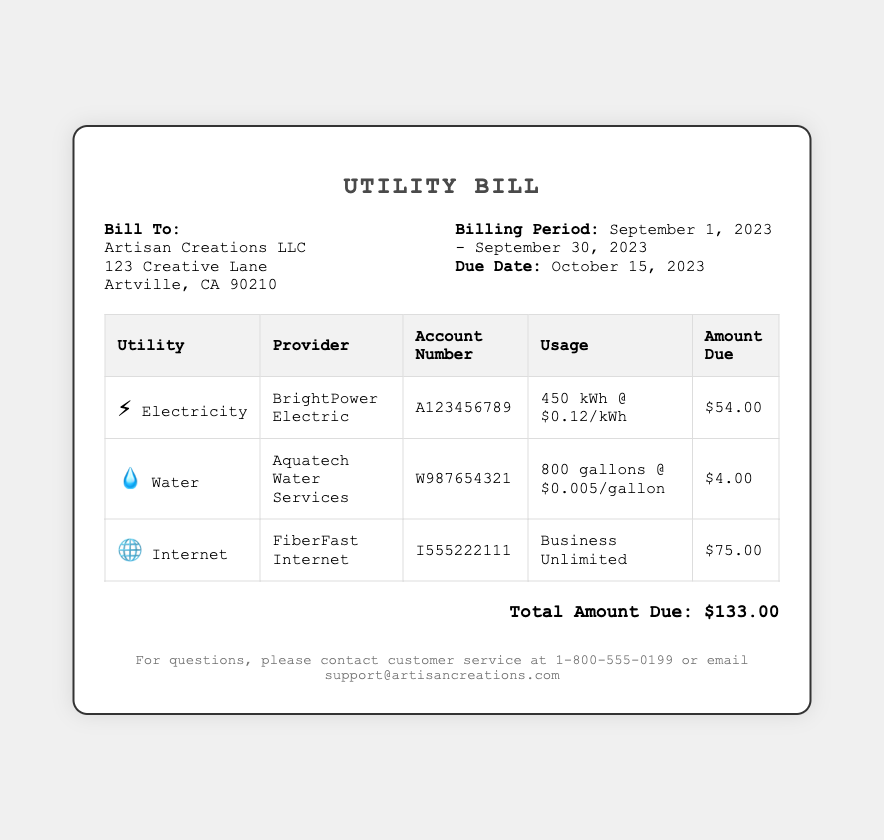What is the total amount due? The total amount due is clearly indicated at the bottom of the bill as $133.00.
Answer: $133.00 Who is the electricity provider? The provider for electricity is stated in the table under the Electricity section.
Answer: BrightPower Electric What is the usage of water? The water usage is detailed in the table showing 800 gallons.
Answer: 800 gallons What is the due date for this bill? The due date is mentioned in the billing details section prominently.
Answer: October 15, 2023 What is the account number for internet service? The account number for internet can be found in the Internet section of the table.
Answer: I555222111 How much is the electricity rate per kilowatt-hour? The rate is specified alongside the electricity usage in the respective section of the bill.
Answer: $0.12/kWh What is the billing period for this utility bill? The billing period is clearly stated in the billing details section at the top of the bill.
Answer: September 1, 2023 - September 30, 2023 Which utility has the highest amount due? By comparing the amounts due in the table, we find the utility with the highest charge.
Answer: Internet How many gallons of water were used? The specific water usage figure is presented in the table under the water section.
Answer: 800 gallons What is the total electricity usage in kWh? The total electricity usage is listed in the table under the Electricity section as kWh.
Answer: 450 kWh 